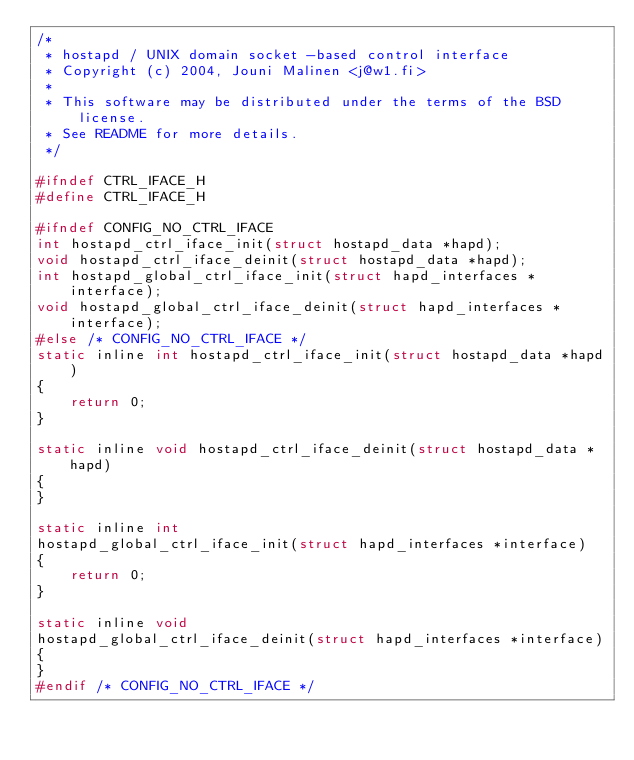<code> <loc_0><loc_0><loc_500><loc_500><_C_>/*
 * hostapd / UNIX domain socket -based control interface
 * Copyright (c) 2004, Jouni Malinen <j@w1.fi>
 *
 * This software may be distributed under the terms of the BSD license.
 * See README for more details.
 */

#ifndef CTRL_IFACE_H
#define CTRL_IFACE_H

#ifndef CONFIG_NO_CTRL_IFACE
int hostapd_ctrl_iface_init(struct hostapd_data *hapd);
void hostapd_ctrl_iface_deinit(struct hostapd_data *hapd);
int hostapd_global_ctrl_iface_init(struct hapd_interfaces *interface);
void hostapd_global_ctrl_iface_deinit(struct hapd_interfaces *interface);
#else /* CONFIG_NO_CTRL_IFACE */
static inline int hostapd_ctrl_iface_init(struct hostapd_data *hapd)
{
	return 0;
}

static inline void hostapd_ctrl_iface_deinit(struct hostapd_data *hapd)
{
}

static inline int
hostapd_global_ctrl_iface_init(struct hapd_interfaces *interface)
{
	return 0;
}

static inline void
hostapd_global_ctrl_iface_deinit(struct hapd_interfaces *interface)
{
}
#endif /* CONFIG_NO_CTRL_IFACE */
</code> 